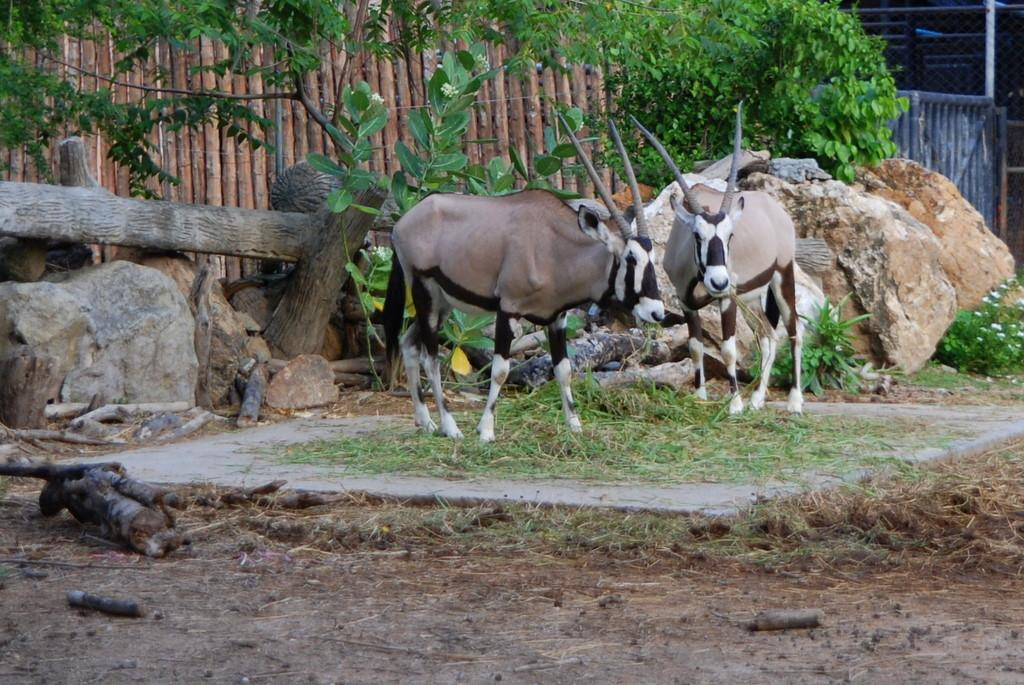What type of animals can be seen in the image? There are gemsbok in the image. What natural elements are present in the image? There are trees, rocks, tree bark, sticks on the ground, grass, and plants with flowers in the image. What type of pets are visible in the image? There are no pets visible in the image; it features gemsbok, which are not domesticated animals. Can you tell me how the gemsbok feel shame in the image? The image does not convey emotions, such as shame, for the gemsbok or any other subject. 